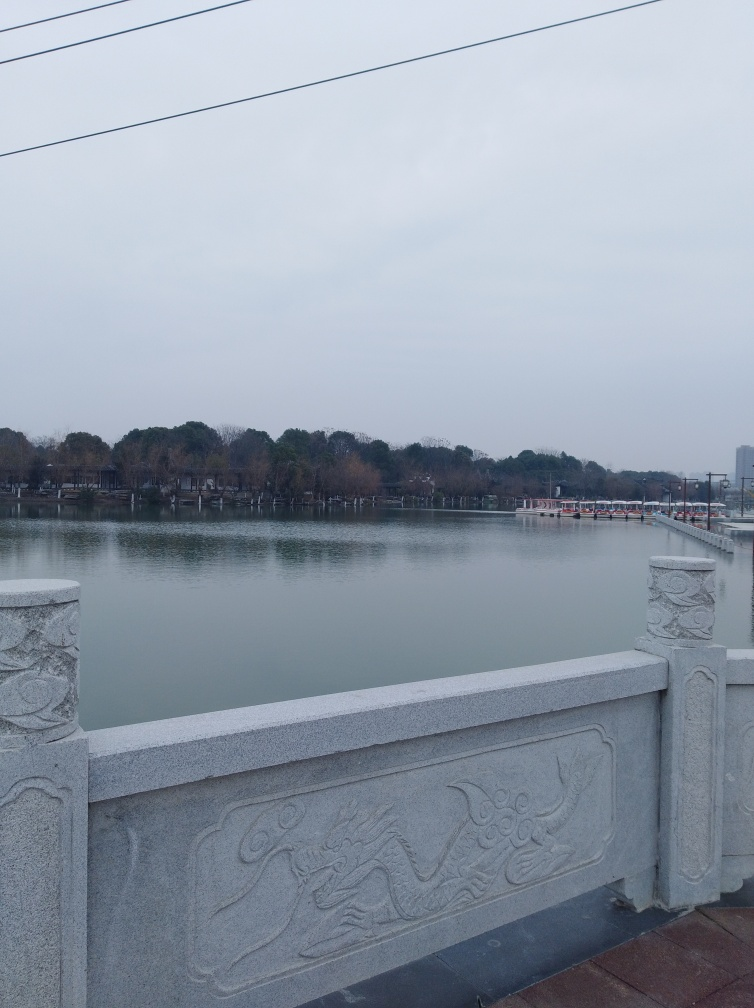Describe the architectural style or details observed on the bridge in the image. The bridge in the image features a balustrade with carved motifs that may draw inspiration from traditional designs, possibly with cultural significance. Such patterns often show the influence of local historical styles, and the stone material gives a sense of solidity and permanence. 